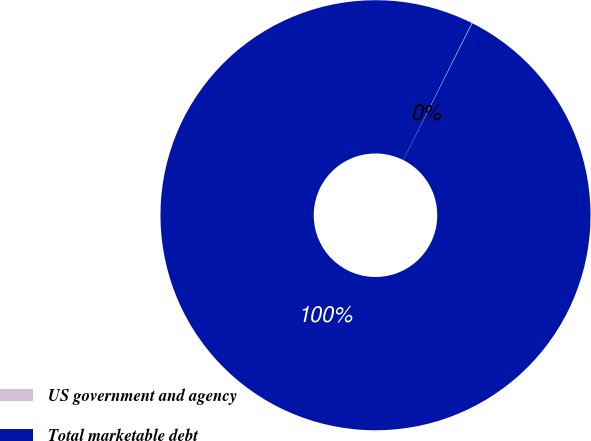Convert chart. <chart><loc_0><loc_0><loc_500><loc_500><pie_chart><fcel>US government and agency<fcel>Total marketable debt<nl><fcel>0.05%<fcel>99.95%<nl></chart> 